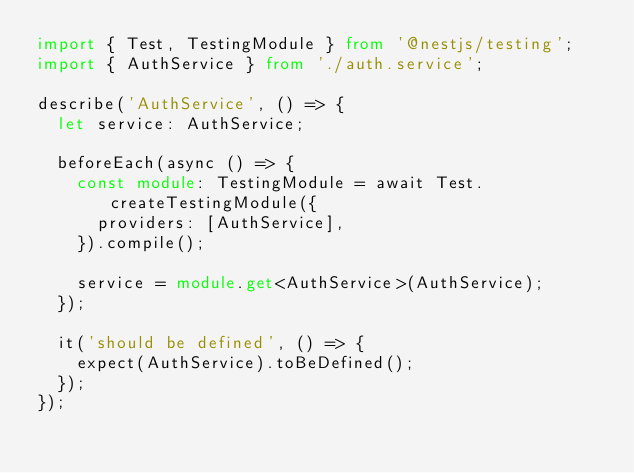Convert code to text. <code><loc_0><loc_0><loc_500><loc_500><_TypeScript_>import { Test, TestingModule } from '@nestjs/testing';
import { AuthService } from './auth.service';

describe('AuthService', () => {
  let service: AuthService;

  beforeEach(async () => {
    const module: TestingModule = await Test.createTestingModule({
      providers: [AuthService],
    }).compile();

    service = module.get<AuthService>(AuthService);
  });

  it('should be defined', () => {
    expect(AuthService).toBeDefined();
  });
});
</code> 